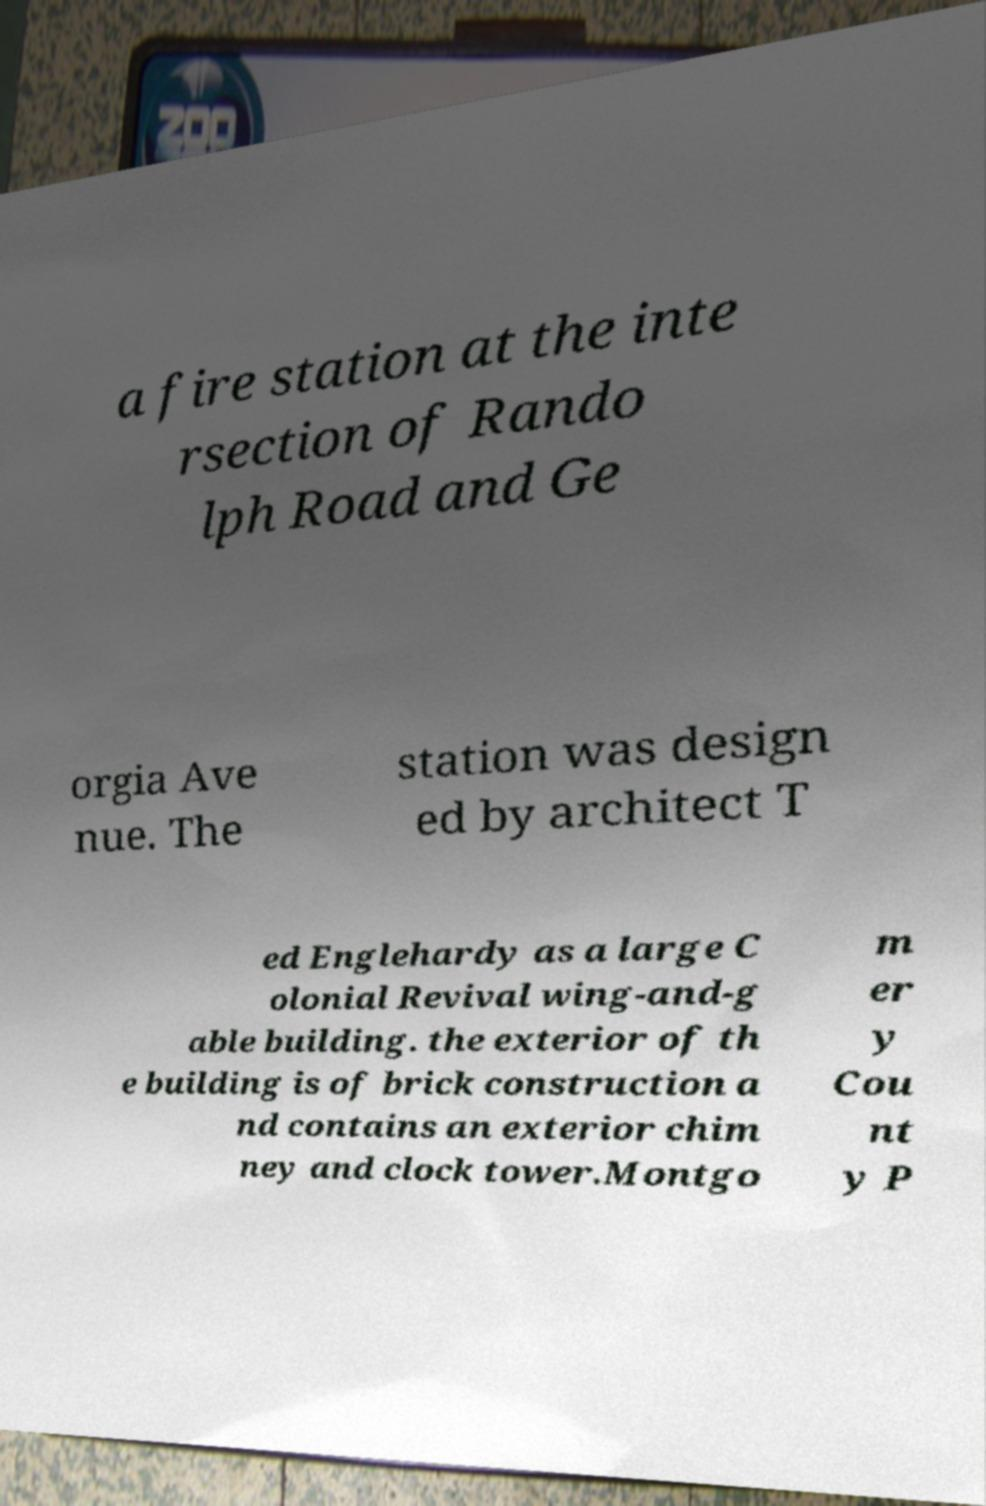What messages or text are displayed in this image? I need them in a readable, typed format. a fire station at the inte rsection of Rando lph Road and Ge orgia Ave nue. The station was design ed by architect T ed Englehardy as a large C olonial Revival wing-and-g able building. the exterior of th e building is of brick construction a nd contains an exterior chim ney and clock tower.Montgo m er y Cou nt y P 